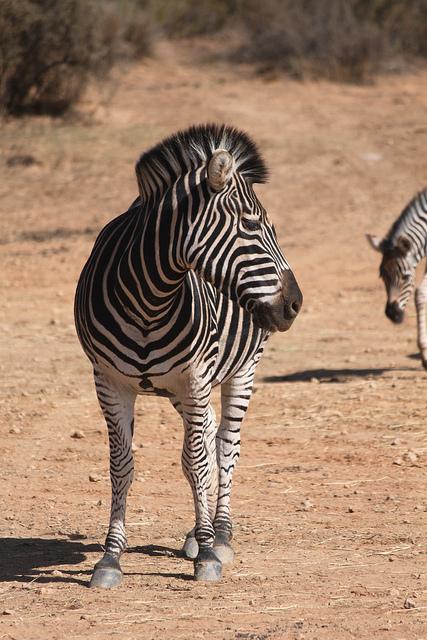What hairstyle is on zebra?
Short answer required. Mohawk. Are the zebras standing on grass?
Write a very short answer. No. What is the zebra looking at?
Give a very brief answer. Another zebra. What kind of surface are the two animals on?
Short answer required. Dirt. Are this adult zebras?
Write a very short answer. Yes. 